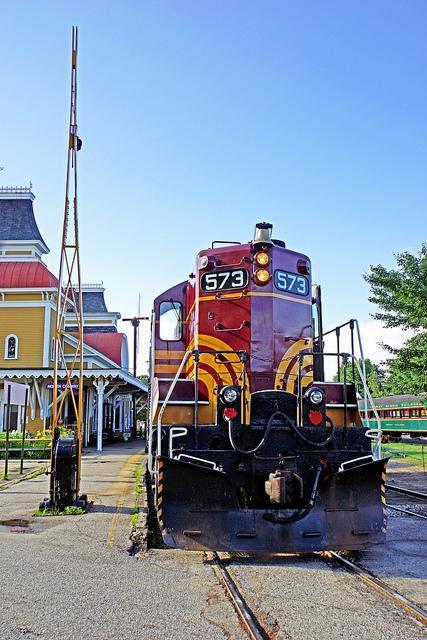How many people are headed towards the train?
Give a very brief answer. 0. How many trains can be seen?
Give a very brief answer. 2. How many cats are on the sink?
Give a very brief answer. 0. 